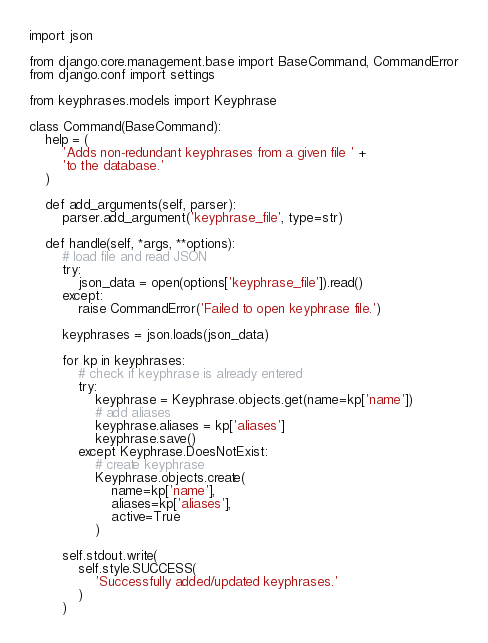Convert code to text. <code><loc_0><loc_0><loc_500><loc_500><_Python_>import json

from django.core.management.base import BaseCommand, CommandError
from django.conf import settings

from keyphrases.models import Keyphrase

class Command(BaseCommand):
    help = (
        'Adds non-redundant keyphrases from a given file ' + 
        'to the database.'
    )

    def add_arguments(self, parser):
        parser.add_argument('keyphrase_file', type=str)

    def handle(self, *args, **options):
        # load file and read JSON
        try:
            json_data = open(options['keyphrase_file']).read()
        except:
            raise CommandError('Failed to open keyphrase file.')

        keyphrases = json.loads(json_data)

        for kp in keyphrases:
            # check if keyphrase is already entered
            try:
                keyphrase = Keyphrase.objects.get(name=kp['name'])
                # add aliases
                keyphrase.aliases = kp['aliases']
                keyphrase.save()
            except Keyphrase.DoesNotExist:
                # create keyphrase
                Keyphrase.objects.create(
                    name=kp['name'],
                    aliases=kp['aliases'],
                    active=True
                )

        self.stdout.write(
            self.style.SUCCESS(
                'Successfully added/updated keyphrases.'
            )
        )</code> 